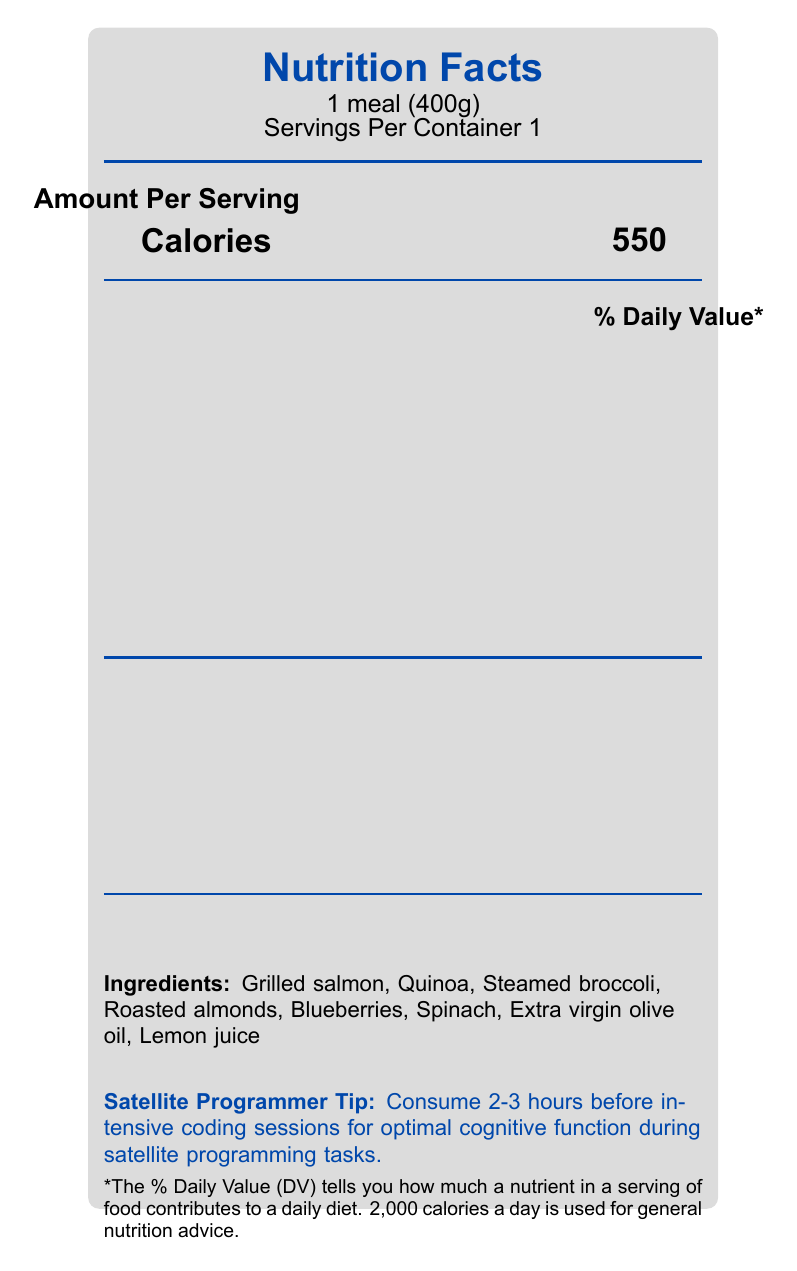what is the serving size? The label specifies that the serving size is "1 meal (400g)".
Answer: 1 meal (400g) how many calories are in one serving? The document indicates that one serving contains 550 calories.
Answer: 550 what percentage of the daily value is the total fat content? The "Total Fat" content is 22g and represents 28% of the daily value.
Answer: 28% how much dietary fiber does the meal contain? The document shows that dietary fiber content is 8g.
Answer: 8g what ingredient provides omega-3 fatty acids? According to the cognitive boosting notes, omega-3 fatty acids are provided by salmon in the ingredient list.
Answer: Grilled salmon which ingredient is not listed in the cognitive boosting notes? A. Blueberries B. Spinach C. Whole wheat bread D. Roasted almonds Whole wheat bread is not listed among the ingredients or cognitive-boosting notes, whereas the others are.
Answer: C. Whole wheat bread what is the percentage daily value of vitamin D? A. 10% B. 15% C. 20% D. 100% The label lists Vitamin D at 10% of the daily value.
Answer: A. 10% are there trans fats in the meal? The label lists Trans Fat as 0g, indicating there are no trans fats.
Answer: No does the meal support cognitive function during satellite programming tasks? The document mentions multiple cognitive boosting notes aimed at enhancing brain function, such as high omega-3 fatty acids, complex carbohydrates, and antioxidants.
Answer: Yes what should you drink while working on satellite algorithms for optimal cognitive function? The satellite programmer tips suggest staying hydrated with water or green tea.
Answer: Water or green tea describe the main idea of this document. The explanation includes the document's purpose, the detailed nutritional breakdown, the highlighted cognitive benefits of specific ingredients, and practical consumption tips for satellite programmers.
Answer: The document is a nutrition facts label for a balanced meal designed to support cognitive function during satellite programming tasks. It details the nutritional content per serving, including calories, fats, proteins, vitamins, and minerals. It highlights specific ingredients and their cognitive benefits, along with tips for satellite programmers on when and how to consume the meal for optimal brain function. is there sufficient information to determine a recommended daily intake of omega-3 fatty acids? The document does not provide a recommended daily intake for omega-3 fatty acids, only the amount present in the meal (1.5g).
Answer: No, not enough information 